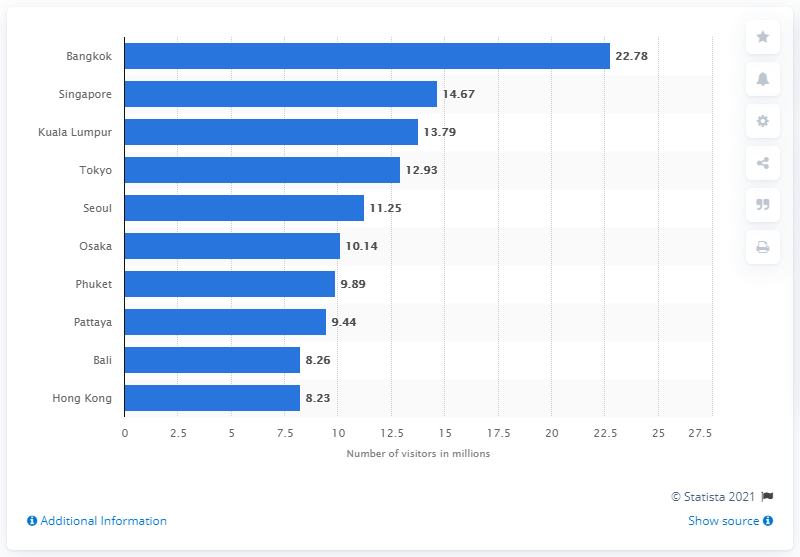What might be the reasons behind Bangkok's popularity among international visitors? Bangkok's popularity can be attributed to its vibrant blend of historical significance, rich culture, famous street food, world-renowned hospitality, and affordability. The city offers a unique experience that mixes traditional Thai culture with modernity, attracting tourists from all walks of life. 